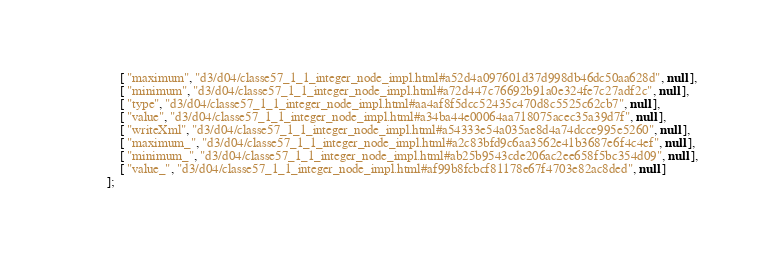Convert code to text. <code><loc_0><loc_0><loc_500><loc_500><_JavaScript_>    [ "maximum", "d3/d04/classe57_1_1_integer_node_impl.html#a52d4a097601d37d998db46dc50aa628d", null ],
    [ "minimum", "d3/d04/classe57_1_1_integer_node_impl.html#a72d447c76692b91a0e324fe7c27adf2c", null ],
    [ "type", "d3/d04/classe57_1_1_integer_node_impl.html#aa4af8f5dcc52435c470d8c5525c62cb7", null ],
    [ "value", "d3/d04/classe57_1_1_integer_node_impl.html#a34ba44e00064aa718075acec35a39d7f", null ],
    [ "writeXml", "d3/d04/classe57_1_1_integer_node_impl.html#a54333e54a035ae8d4a74dcce995e5260", null ],
    [ "maximum_", "d3/d04/classe57_1_1_integer_node_impl.html#a2c83bfd9c6aa3562e41b3687e6f4c4ef", null ],
    [ "minimum_", "d3/d04/classe57_1_1_integer_node_impl.html#ab25b9543cde206ac2ee658f5bc354d09", null ],
    [ "value_", "d3/d04/classe57_1_1_integer_node_impl.html#af99b8fcbcf81178e67f4703e82ac8ded", null ]
];</code> 